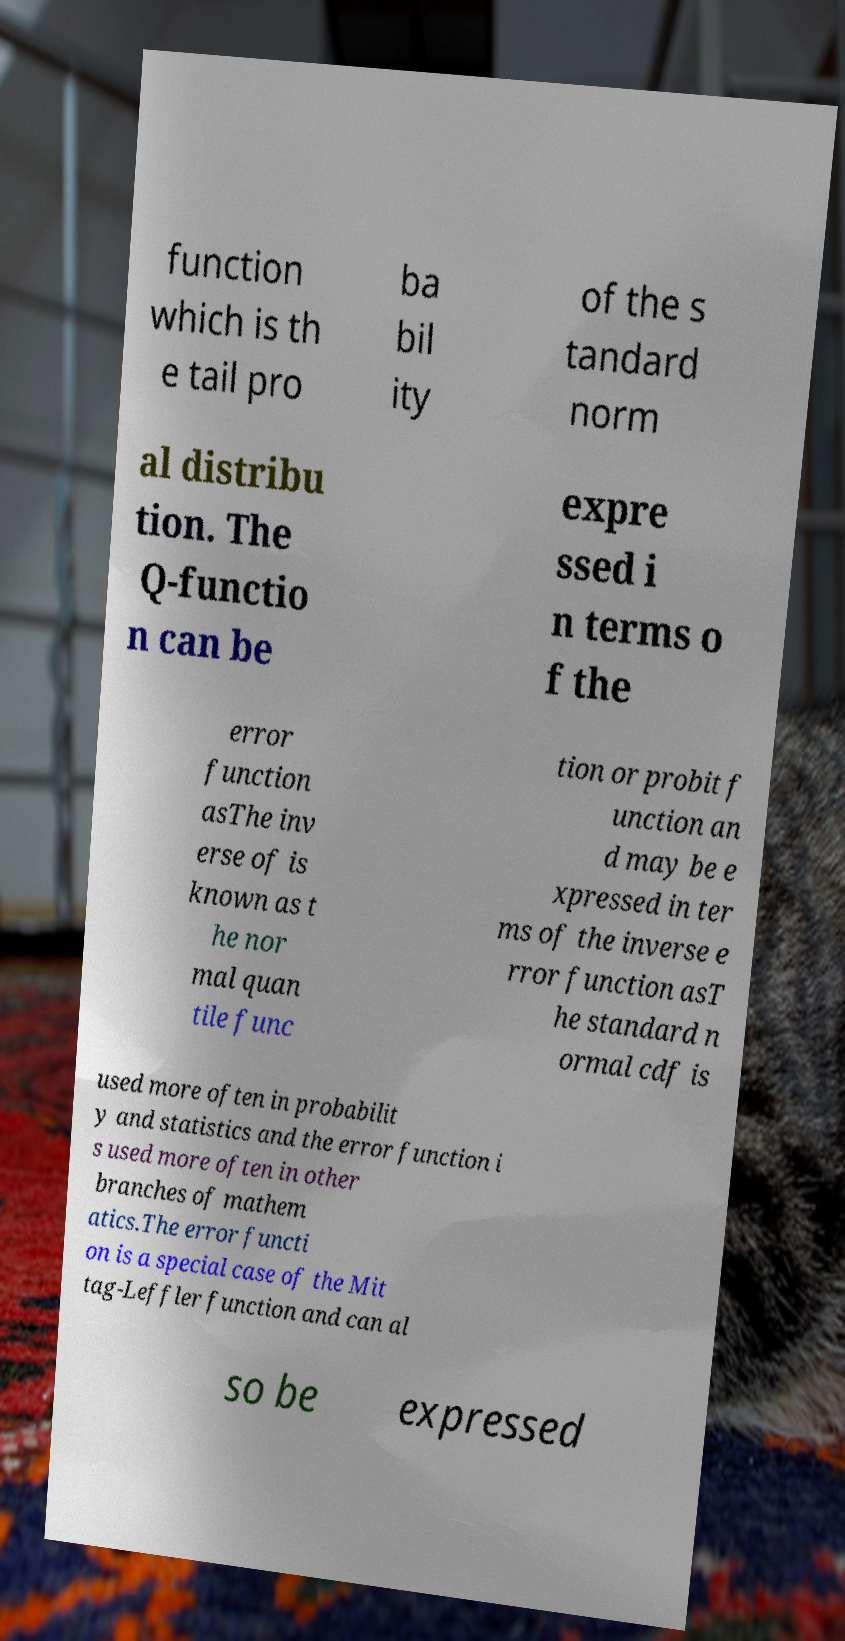There's text embedded in this image that I need extracted. Can you transcribe it verbatim? function which is th e tail pro ba bil ity of the s tandard norm al distribu tion. The Q-functio n can be expre ssed i n terms o f the error function asThe inv erse of is known as t he nor mal quan tile func tion or probit f unction an d may be e xpressed in ter ms of the inverse e rror function asT he standard n ormal cdf is used more often in probabilit y and statistics and the error function i s used more often in other branches of mathem atics.The error functi on is a special case of the Mit tag-Leffler function and can al so be expressed 